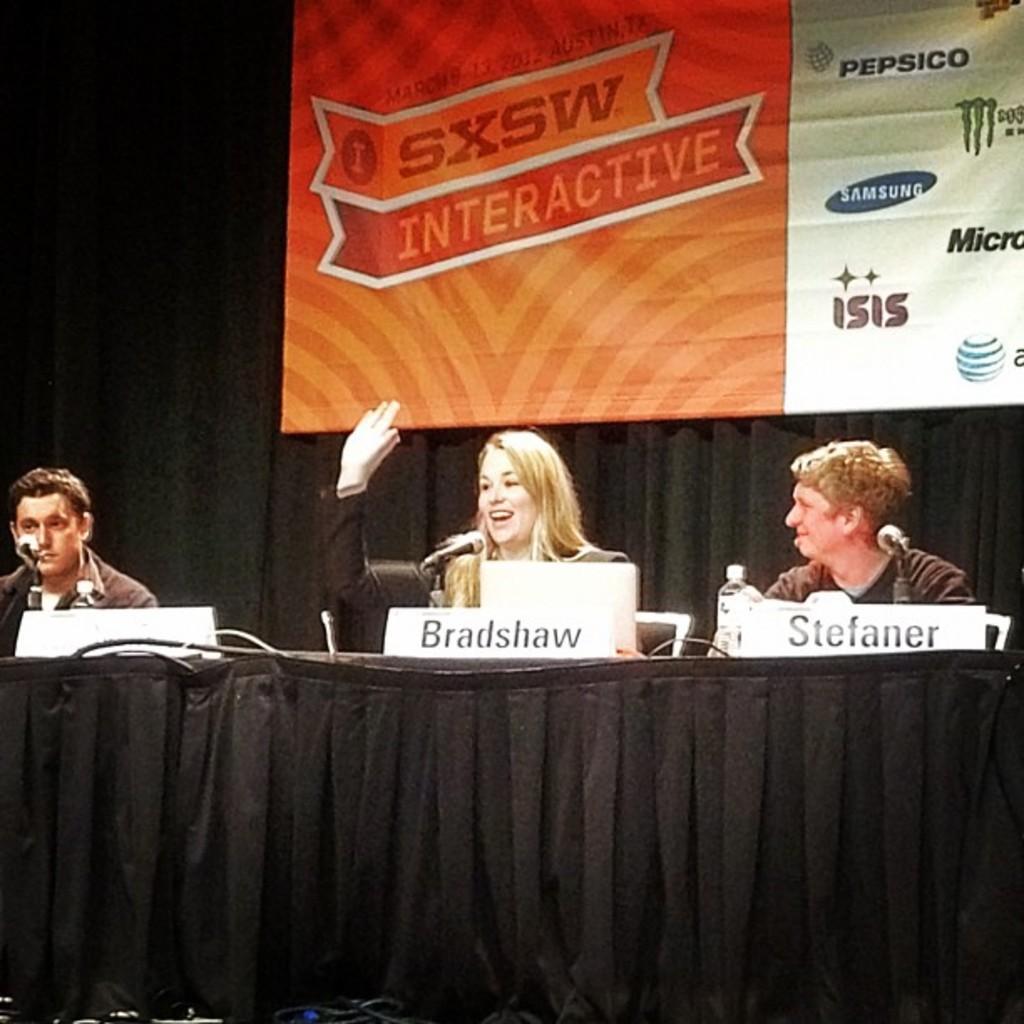Please provide a concise description of this image. this picture shows three people seated and we see microphones in front of them and hoarding back of them 